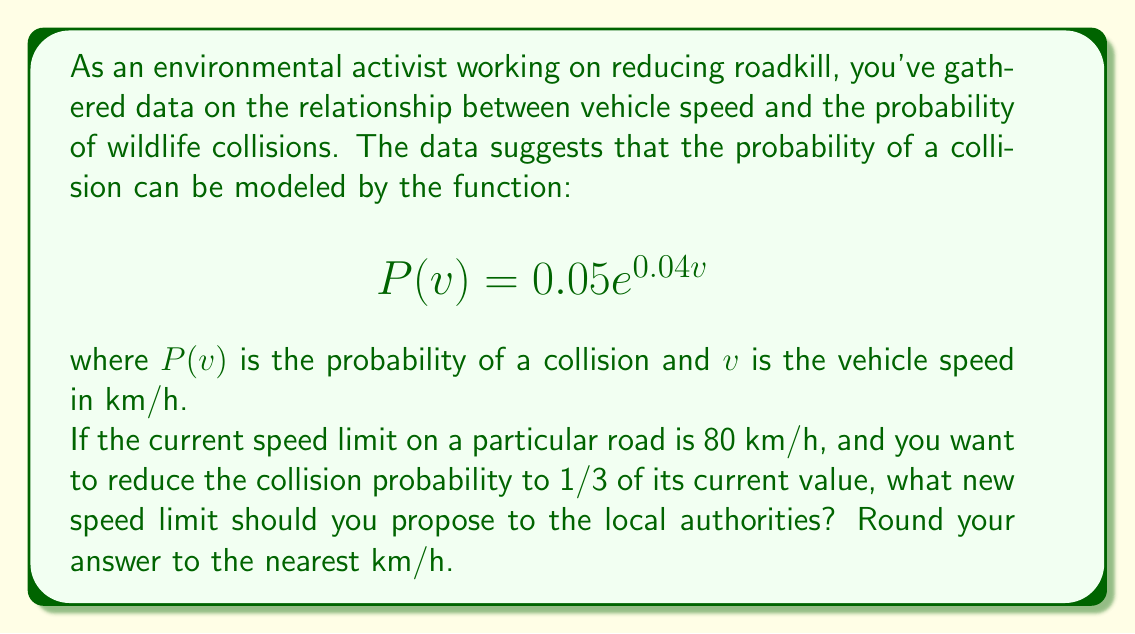Help me with this question. Let's approach this step-by-step:

1) First, we need to find the current probability of collision at 80 km/h:
   $$P(80) = 0.05e^{0.04(80)} = 0.05e^{3.2} \approx 1.2214$$

2) We want to reduce this probability to 1/3 of its current value:
   $$\text{New Probability} = \frac{1}{3} \times 1.2214 \approx 0.4071$$

3) Now, we need to find the speed $v$ that gives this new probability:
   $$0.4071 = 0.05e^{0.04v}$$

4) Divide both sides by 0.05:
   $$8.142 = e^{0.04v}$$

5) Take the natural logarithm of both sides:
   $$\ln(8.142) = 0.04v$$

6) Solve for $v$:
   $$v = \frac{\ln(8.142)}{0.04} \approx 52.37$$

7) Rounding to the nearest km/h:
   $$v \approx 52 \text{ km/h}$$
Answer: 52 km/h 